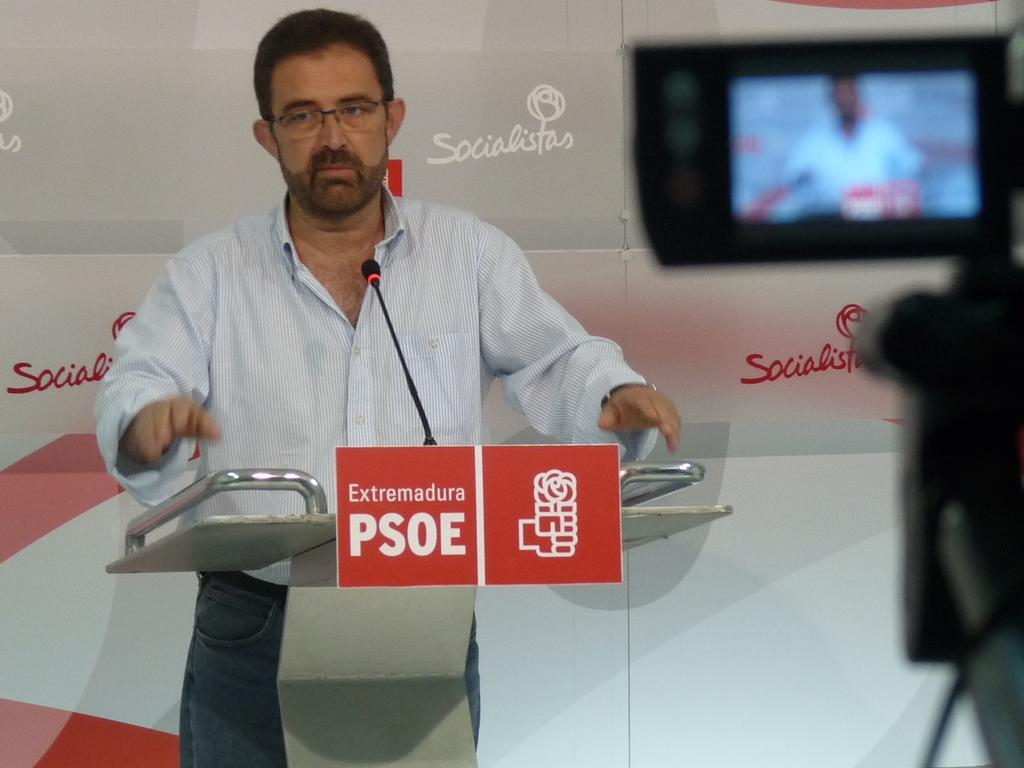Describe this image in one or two sentences. A man is standing at the podium and on it there is a microphone and two small boards. In the background there is a hoarding and on the right we can see a camera. 